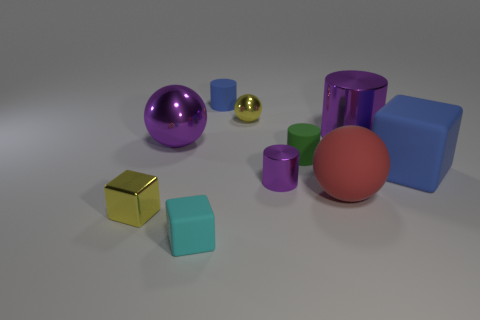Subtract all cylinders. How many objects are left? 6 Add 5 small metallic cubes. How many small metallic cubes are left? 6 Add 5 big purple cylinders. How many big purple cylinders exist? 6 Subtract 0 brown blocks. How many objects are left? 10 Subtract all large gray cylinders. Subtract all tiny blue things. How many objects are left? 9 